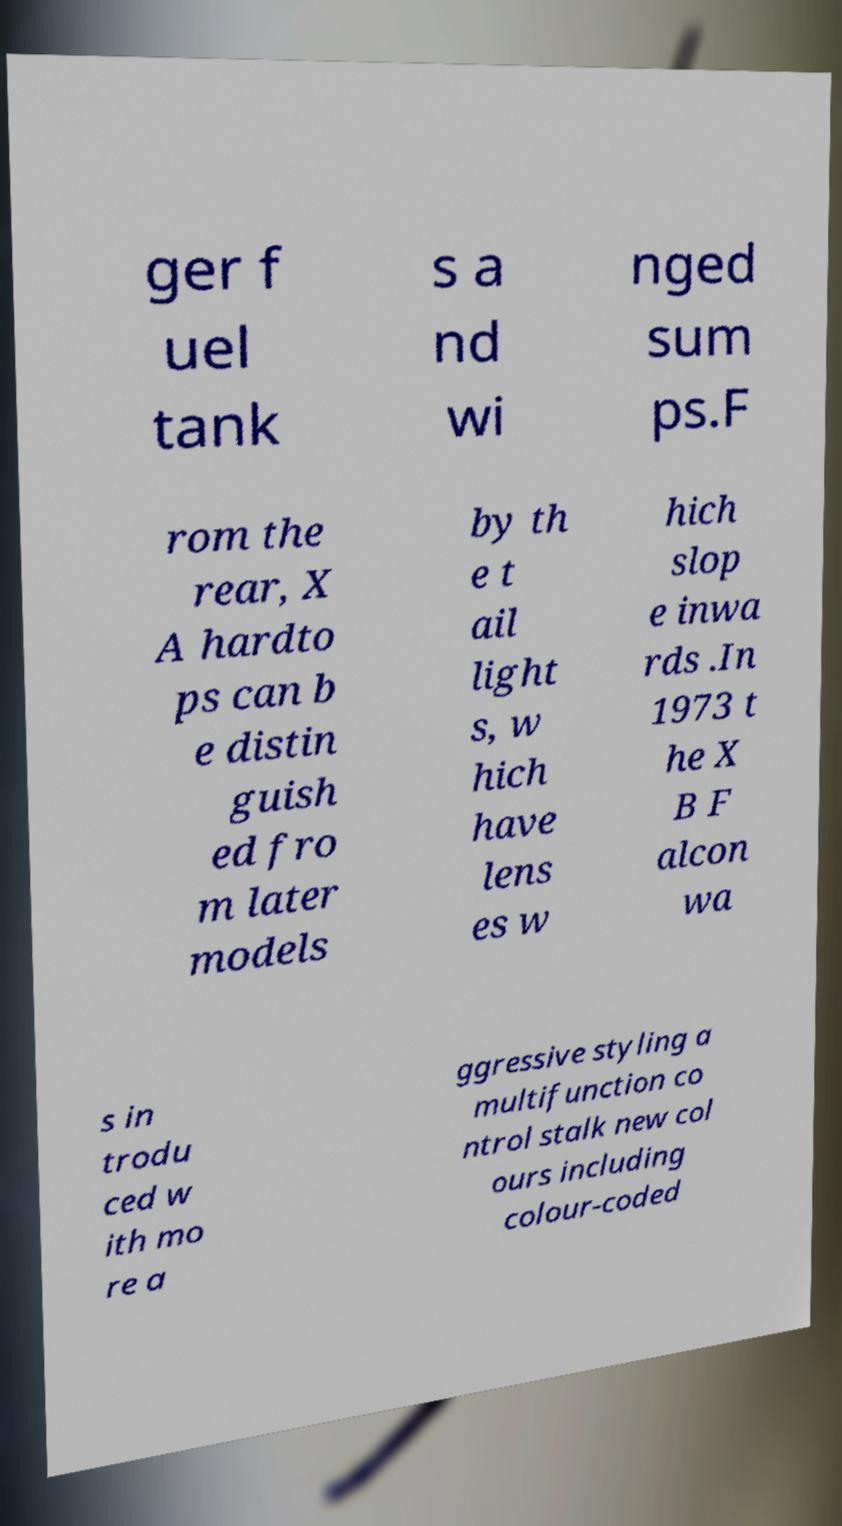Can you accurately transcribe the text from the provided image for me? ger f uel tank s a nd wi nged sum ps.F rom the rear, X A hardto ps can b e distin guish ed fro m later models by th e t ail light s, w hich have lens es w hich slop e inwa rds .In 1973 t he X B F alcon wa s in trodu ced w ith mo re a ggressive styling a multifunction co ntrol stalk new col ours including colour-coded 